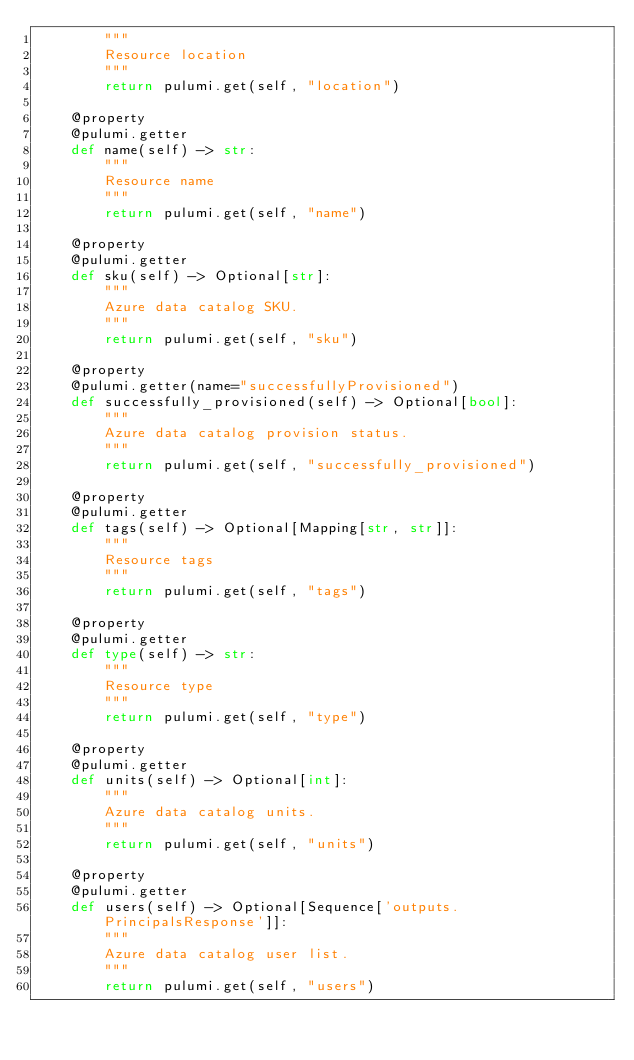Convert code to text. <code><loc_0><loc_0><loc_500><loc_500><_Python_>        """
        Resource location
        """
        return pulumi.get(self, "location")

    @property
    @pulumi.getter
    def name(self) -> str:
        """
        Resource name
        """
        return pulumi.get(self, "name")

    @property
    @pulumi.getter
    def sku(self) -> Optional[str]:
        """
        Azure data catalog SKU.
        """
        return pulumi.get(self, "sku")

    @property
    @pulumi.getter(name="successfullyProvisioned")
    def successfully_provisioned(self) -> Optional[bool]:
        """
        Azure data catalog provision status.
        """
        return pulumi.get(self, "successfully_provisioned")

    @property
    @pulumi.getter
    def tags(self) -> Optional[Mapping[str, str]]:
        """
        Resource tags
        """
        return pulumi.get(self, "tags")

    @property
    @pulumi.getter
    def type(self) -> str:
        """
        Resource type
        """
        return pulumi.get(self, "type")

    @property
    @pulumi.getter
    def units(self) -> Optional[int]:
        """
        Azure data catalog units.
        """
        return pulumi.get(self, "units")

    @property
    @pulumi.getter
    def users(self) -> Optional[Sequence['outputs.PrincipalsResponse']]:
        """
        Azure data catalog user list.
        """
        return pulumi.get(self, "users")

</code> 